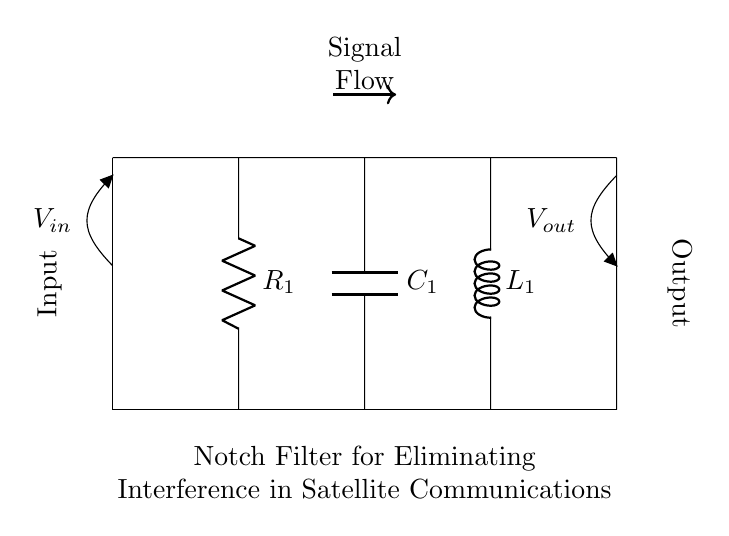What are the components used in this notch filter circuit? The components are a resistor, a capacitor, and an inductor, which are identified as R1, C1, and L1, respectively in the diagram.
Answer: Resistor, Capacitor, Inductor What is the purpose of the notch filter in satellite communications? The purpose is to eliminate known interference frequencies from the signal, enhancing the clarity and quality of satellite communication.
Answer: Eliminate interference What is the input to the circuit? The input is indicated as V in or voltage at the input terminal, marked at the left side of the circuit.
Answer: V in How many components are in series in this circuit? All three components R1, C1, and L1 are connected in series, forming one path for current to flow through sequentially.
Answer: Three What effect does the capacitor have in this notch filter? The capacitor introduces a reactance that can block certain frequencies, working in conjunction with the other components to create a notch at the targeted interference frequency.
Answer: Blocks frequencies What is the expected output voltage when the notch filter operates correctly? The output voltage will ideally be the input voltage minus the voltage at the notch frequency, which is minimized or ideally zero where the filter is effective.
Answer: Depends on the input frequency What type of filter is represented in this circuit diagram? The filter represented is a notch filter, specifically designed to attenuate a narrow band of frequencies while allowing others to pass.
Answer: Notch filter 